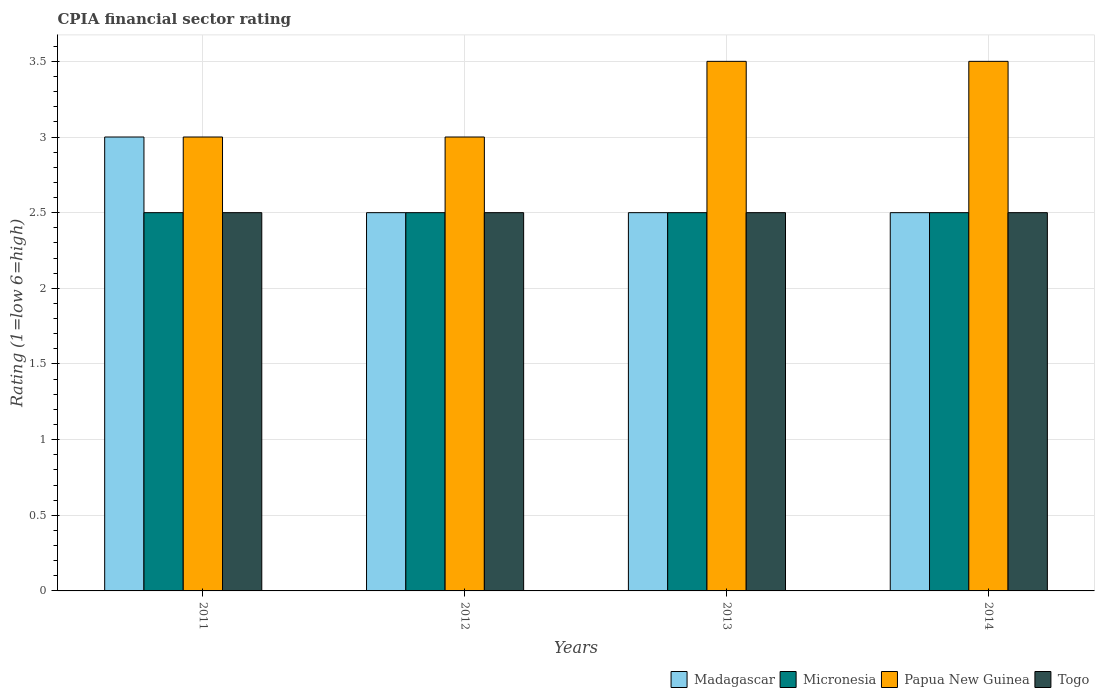How many different coloured bars are there?
Your response must be concise. 4. Are the number of bars per tick equal to the number of legend labels?
Offer a terse response. Yes. Are the number of bars on each tick of the X-axis equal?
Your answer should be compact. Yes. How many bars are there on the 2nd tick from the left?
Your answer should be compact. 4. In how many cases, is the number of bars for a given year not equal to the number of legend labels?
Offer a terse response. 0. In which year was the CPIA rating in Togo minimum?
Make the answer very short. 2011. What is the total CPIA rating in Papua New Guinea in the graph?
Give a very brief answer. 13. What is the difference between the CPIA rating in Papua New Guinea in 2011 and that in 2012?
Your answer should be compact. 0. What is the difference between the CPIA rating in Madagascar in 2012 and the CPIA rating in Papua New Guinea in 2013?
Your answer should be compact. -1. What is the average CPIA rating in Madagascar per year?
Offer a very short reply. 2.62. In the year 2011, what is the difference between the CPIA rating in Micronesia and CPIA rating in Madagascar?
Offer a terse response. -0.5. In how many years, is the CPIA rating in Micronesia greater than 0.6?
Make the answer very short. 4. What is the difference between the highest and the second highest CPIA rating in Madagascar?
Offer a very short reply. 0.5. What does the 3rd bar from the left in 2012 represents?
Keep it short and to the point. Papua New Guinea. What does the 1st bar from the right in 2011 represents?
Provide a short and direct response. Togo. Is it the case that in every year, the sum of the CPIA rating in Papua New Guinea and CPIA rating in Togo is greater than the CPIA rating in Micronesia?
Your answer should be compact. Yes. How many years are there in the graph?
Your response must be concise. 4. What is the difference between two consecutive major ticks on the Y-axis?
Give a very brief answer. 0.5. Are the values on the major ticks of Y-axis written in scientific E-notation?
Make the answer very short. No. Does the graph contain any zero values?
Ensure brevity in your answer.  No. Where does the legend appear in the graph?
Offer a terse response. Bottom right. How are the legend labels stacked?
Your response must be concise. Horizontal. What is the title of the graph?
Ensure brevity in your answer.  CPIA financial sector rating. What is the label or title of the X-axis?
Your answer should be compact. Years. What is the label or title of the Y-axis?
Provide a short and direct response. Rating (1=low 6=high). What is the Rating (1=low 6=high) in Madagascar in 2011?
Provide a short and direct response. 3. What is the Rating (1=low 6=high) of Micronesia in 2011?
Provide a succinct answer. 2.5. What is the Rating (1=low 6=high) in Madagascar in 2012?
Offer a terse response. 2.5. What is the Rating (1=low 6=high) in Papua New Guinea in 2012?
Offer a very short reply. 3. What is the Rating (1=low 6=high) in Togo in 2012?
Provide a succinct answer. 2.5. What is the Rating (1=low 6=high) of Madagascar in 2013?
Ensure brevity in your answer.  2.5. What is the Rating (1=low 6=high) in Micronesia in 2013?
Your answer should be very brief. 2.5. What is the Rating (1=low 6=high) of Madagascar in 2014?
Your response must be concise. 2.5. What is the Rating (1=low 6=high) of Papua New Guinea in 2014?
Provide a succinct answer. 3.5. What is the Rating (1=low 6=high) of Togo in 2014?
Provide a succinct answer. 2.5. Across all years, what is the minimum Rating (1=low 6=high) of Madagascar?
Your answer should be compact. 2.5. Across all years, what is the minimum Rating (1=low 6=high) of Micronesia?
Provide a short and direct response. 2.5. Across all years, what is the minimum Rating (1=low 6=high) in Papua New Guinea?
Ensure brevity in your answer.  3. What is the total Rating (1=low 6=high) in Micronesia in the graph?
Make the answer very short. 10. What is the total Rating (1=low 6=high) of Togo in the graph?
Offer a very short reply. 10. What is the difference between the Rating (1=low 6=high) in Togo in 2011 and that in 2012?
Provide a short and direct response. 0. What is the difference between the Rating (1=low 6=high) in Madagascar in 2011 and that in 2013?
Ensure brevity in your answer.  0.5. What is the difference between the Rating (1=low 6=high) of Togo in 2011 and that in 2013?
Offer a terse response. 0. What is the difference between the Rating (1=low 6=high) in Micronesia in 2011 and that in 2014?
Offer a terse response. 0. What is the difference between the Rating (1=low 6=high) in Papua New Guinea in 2011 and that in 2014?
Provide a succinct answer. -0.5. What is the difference between the Rating (1=low 6=high) in Togo in 2011 and that in 2014?
Provide a short and direct response. 0. What is the difference between the Rating (1=low 6=high) in Togo in 2012 and that in 2013?
Your answer should be compact. 0. What is the difference between the Rating (1=low 6=high) of Madagascar in 2012 and that in 2014?
Ensure brevity in your answer.  0. What is the difference between the Rating (1=low 6=high) of Madagascar in 2013 and that in 2014?
Provide a succinct answer. 0. What is the difference between the Rating (1=low 6=high) of Micronesia in 2013 and that in 2014?
Offer a terse response. 0. What is the difference between the Rating (1=low 6=high) of Papua New Guinea in 2013 and that in 2014?
Your response must be concise. 0. What is the difference between the Rating (1=low 6=high) in Togo in 2013 and that in 2014?
Offer a terse response. 0. What is the difference between the Rating (1=low 6=high) of Madagascar in 2011 and the Rating (1=low 6=high) of Micronesia in 2012?
Your answer should be compact. 0.5. What is the difference between the Rating (1=low 6=high) of Micronesia in 2011 and the Rating (1=low 6=high) of Papua New Guinea in 2012?
Your answer should be compact. -0.5. What is the difference between the Rating (1=low 6=high) in Micronesia in 2011 and the Rating (1=low 6=high) in Togo in 2012?
Your response must be concise. 0. What is the difference between the Rating (1=low 6=high) of Madagascar in 2011 and the Rating (1=low 6=high) of Papua New Guinea in 2013?
Keep it short and to the point. -0.5. What is the difference between the Rating (1=low 6=high) of Micronesia in 2011 and the Rating (1=low 6=high) of Papua New Guinea in 2013?
Keep it short and to the point. -1. What is the difference between the Rating (1=low 6=high) in Madagascar in 2011 and the Rating (1=low 6=high) in Papua New Guinea in 2014?
Provide a short and direct response. -0.5. What is the difference between the Rating (1=low 6=high) of Madagascar in 2011 and the Rating (1=low 6=high) of Togo in 2014?
Offer a very short reply. 0.5. What is the difference between the Rating (1=low 6=high) in Micronesia in 2011 and the Rating (1=low 6=high) in Papua New Guinea in 2014?
Your answer should be compact. -1. What is the difference between the Rating (1=low 6=high) in Micronesia in 2011 and the Rating (1=low 6=high) in Togo in 2014?
Your answer should be very brief. 0. What is the difference between the Rating (1=low 6=high) of Madagascar in 2012 and the Rating (1=low 6=high) of Togo in 2013?
Keep it short and to the point. 0. What is the difference between the Rating (1=low 6=high) in Micronesia in 2012 and the Rating (1=low 6=high) in Togo in 2013?
Your answer should be compact. 0. What is the difference between the Rating (1=low 6=high) of Madagascar in 2012 and the Rating (1=low 6=high) of Papua New Guinea in 2014?
Provide a succinct answer. -1. What is the difference between the Rating (1=low 6=high) of Madagascar in 2012 and the Rating (1=low 6=high) of Togo in 2014?
Offer a very short reply. 0. What is the difference between the Rating (1=low 6=high) in Micronesia in 2012 and the Rating (1=low 6=high) in Togo in 2014?
Ensure brevity in your answer.  0. What is the difference between the Rating (1=low 6=high) of Madagascar in 2013 and the Rating (1=low 6=high) of Micronesia in 2014?
Offer a very short reply. 0. What is the difference between the Rating (1=low 6=high) of Micronesia in 2013 and the Rating (1=low 6=high) of Papua New Guinea in 2014?
Offer a very short reply. -1. What is the average Rating (1=low 6=high) of Madagascar per year?
Offer a very short reply. 2.62. What is the average Rating (1=low 6=high) in Micronesia per year?
Provide a short and direct response. 2.5. What is the average Rating (1=low 6=high) in Togo per year?
Make the answer very short. 2.5. In the year 2011, what is the difference between the Rating (1=low 6=high) of Madagascar and Rating (1=low 6=high) of Papua New Guinea?
Offer a terse response. 0. In the year 2012, what is the difference between the Rating (1=low 6=high) in Micronesia and Rating (1=low 6=high) in Papua New Guinea?
Offer a very short reply. -0.5. In the year 2012, what is the difference between the Rating (1=low 6=high) of Micronesia and Rating (1=low 6=high) of Togo?
Your answer should be compact. 0. In the year 2013, what is the difference between the Rating (1=low 6=high) of Madagascar and Rating (1=low 6=high) of Micronesia?
Give a very brief answer. 0. In the year 2013, what is the difference between the Rating (1=low 6=high) in Madagascar and Rating (1=low 6=high) in Papua New Guinea?
Ensure brevity in your answer.  -1. In the year 2013, what is the difference between the Rating (1=low 6=high) in Micronesia and Rating (1=low 6=high) in Papua New Guinea?
Keep it short and to the point. -1. In the year 2013, what is the difference between the Rating (1=low 6=high) in Papua New Guinea and Rating (1=low 6=high) in Togo?
Provide a succinct answer. 1. In the year 2014, what is the difference between the Rating (1=low 6=high) of Madagascar and Rating (1=low 6=high) of Micronesia?
Offer a terse response. 0. In the year 2014, what is the difference between the Rating (1=low 6=high) in Micronesia and Rating (1=low 6=high) in Papua New Guinea?
Provide a succinct answer. -1. What is the ratio of the Rating (1=low 6=high) of Madagascar in 2011 to that in 2012?
Offer a terse response. 1.2. What is the ratio of the Rating (1=low 6=high) of Papua New Guinea in 2011 to that in 2012?
Your answer should be very brief. 1. What is the ratio of the Rating (1=low 6=high) in Togo in 2011 to that in 2012?
Your response must be concise. 1. What is the ratio of the Rating (1=low 6=high) of Madagascar in 2011 to that in 2014?
Keep it short and to the point. 1.2. What is the ratio of the Rating (1=low 6=high) of Micronesia in 2012 to that in 2013?
Your answer should be compact. 1. What is the ratio of the Rating (1=low 6=high) in Papua New Guinea in 2012 to that in 2013?
Make the answer very short. 0.86. What is the ratio of the Rating (1=low 6=high) of Togo in 2012 to that in 2013?
Offer a very short reply. 1. What is the ratio of the Rating (1=low 6=high) of Micronesia in 2012 to that in 2014?
Ensure brevity in your answer.  1. What is the ratio of the Rating (1=low 6=high) in Papua New Guinea in 2012 to that in 2014?
Offer a terse response. 0.86. What is the ratio of the Rating (1=low 6=high) of Togo in 2012 to that in 2014?
Give a very brief answer. 1. What is the ratio of the Rating (1=low 6=high) in Madagascar in 2013 to that in 2014?
Ensure brevity in your answer.  1. What is the ratio of the Rating (1=low 6=high) in Micronesia in 2013 to that in 2014?
Provide a short and direct response. 1. What is the difference between the highest and the second highest Rating (1=low 6=high) in Madagascar?
Your response must be concise. 0.5. What is the difference between the highest and the lowest Rating (1=low 6=high) of Papua New Guinea?
Keep it short and to the point. 0.5. 